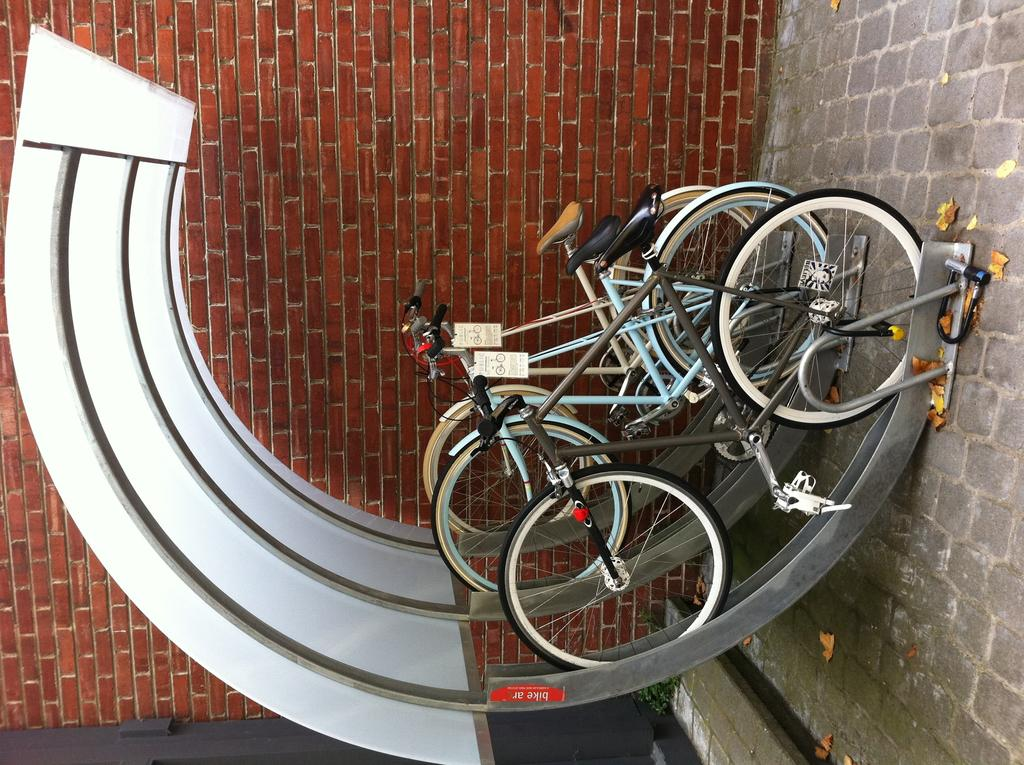How many bicycles are visible in the image? There are three bicycles in the image. Where are the bicycles located? The bicycles are placed in a stand. What color is the wall in the background of the image? There is a red color wall in the background of the image. How many beds can be seen in the image? There are no beds present in the image; it features three bicycles in a stand with a red color wall in the background. 